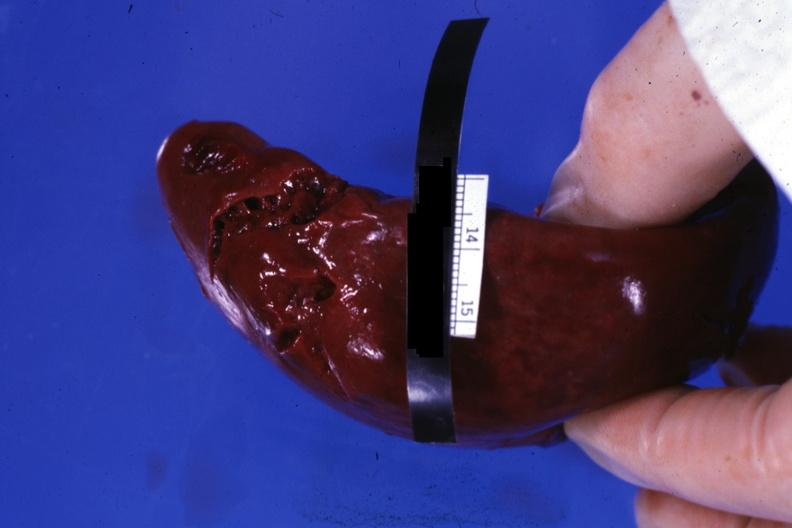what is present?
Answer the question using a single word or phrase. Traumatic rupture 